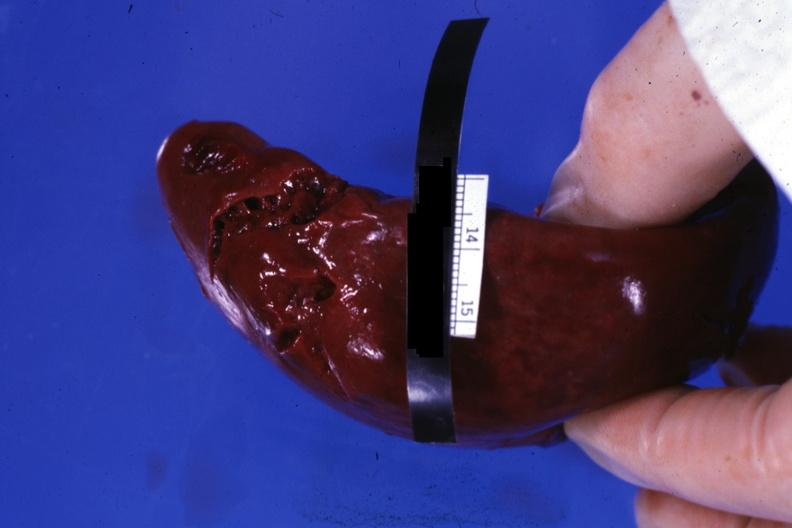what is present?
Answer the question using a single word or phrase. Traumatic rupture 